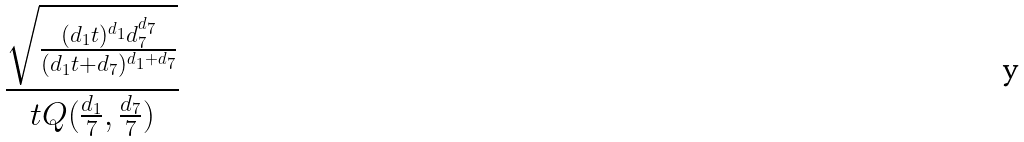Convert formula to latex. <formula><loc_0><loc_0><loc_500><loc_500>\frac { \sqrt { \frac { ( d _ { 1 } t ) ^ { d _ { 1 } } d _ { 7 } ^ { d _ { 7 } } } { ( d _ { 1 } t + d _ { 7 } ) ^ { d _ { 1 } + d _ { 7 } } } } } { t Q ( \frac { d _ { 1 } } { 7 } , \frac { d _ { 7 } } { 7 } ) }</formula> 